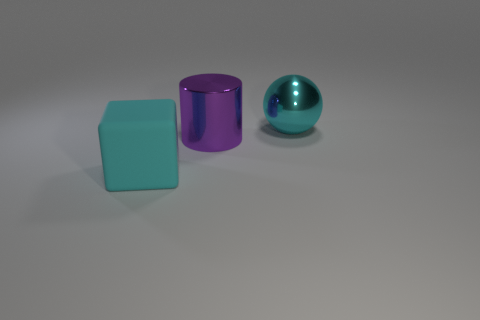Add 1 cyan shiny things. How many objects exist? 4 Add 2 cyan blocks. How many cyan blocks exist? 3 Subtract 0 red cylinders. How many objects are left? 3 Subtract all blocks. How many objects are left? 2 Subtract all red balls. Subtract all purple cylinders. How many balls are left? 1 Subtract all large red metal objects. Subtract all matte cubes. How many objects are left? 2 Add 1 big purple objects. How many big purple objects are left? 2 